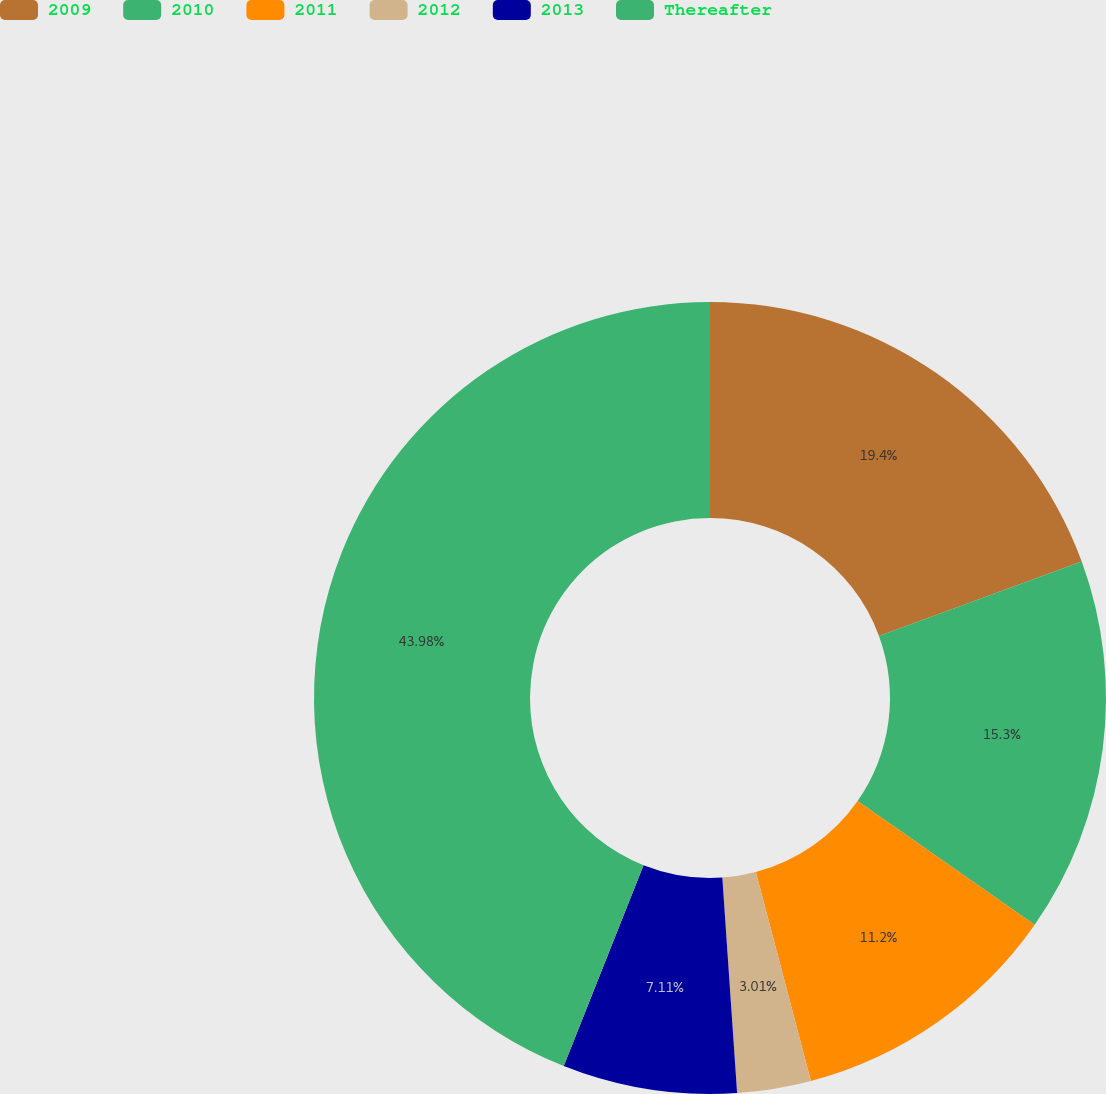<chart> <loc_0><loc_0><loc_500><loc_500><pie_chart><fcel>2009<fcel>2010<fcel>2011<fcel>2012<fcel>2013<fcel>Thereafter<nl><fcel>19.4%<fcel>15.3%<fcel>11.2%<fcel>3.01%<fcel>7.11%<fcel>43.98%<nl></chart> 